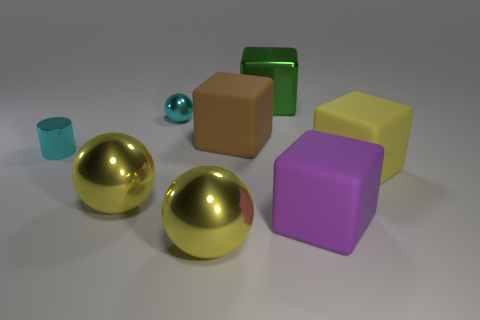Subtract 2 cubes. How many cubes are left? 2 Subtract all cyan blocks. Subtract all yellow cylinders. How many blocks are left? 4 Add 2 brown matte things. How many objects exist? 10 Subtract all balls. How many objects are left? 5 Add 6 big green shiny objects. How many big green shiny objects are left? 7 Add 1 large brown things. How many large brown things exist? 2 Subtract 0 blue cubes. How many objects are left? 8 Subtract all big red cylinders. Subtract all large brown rubber objects. How many objects are left? 7 